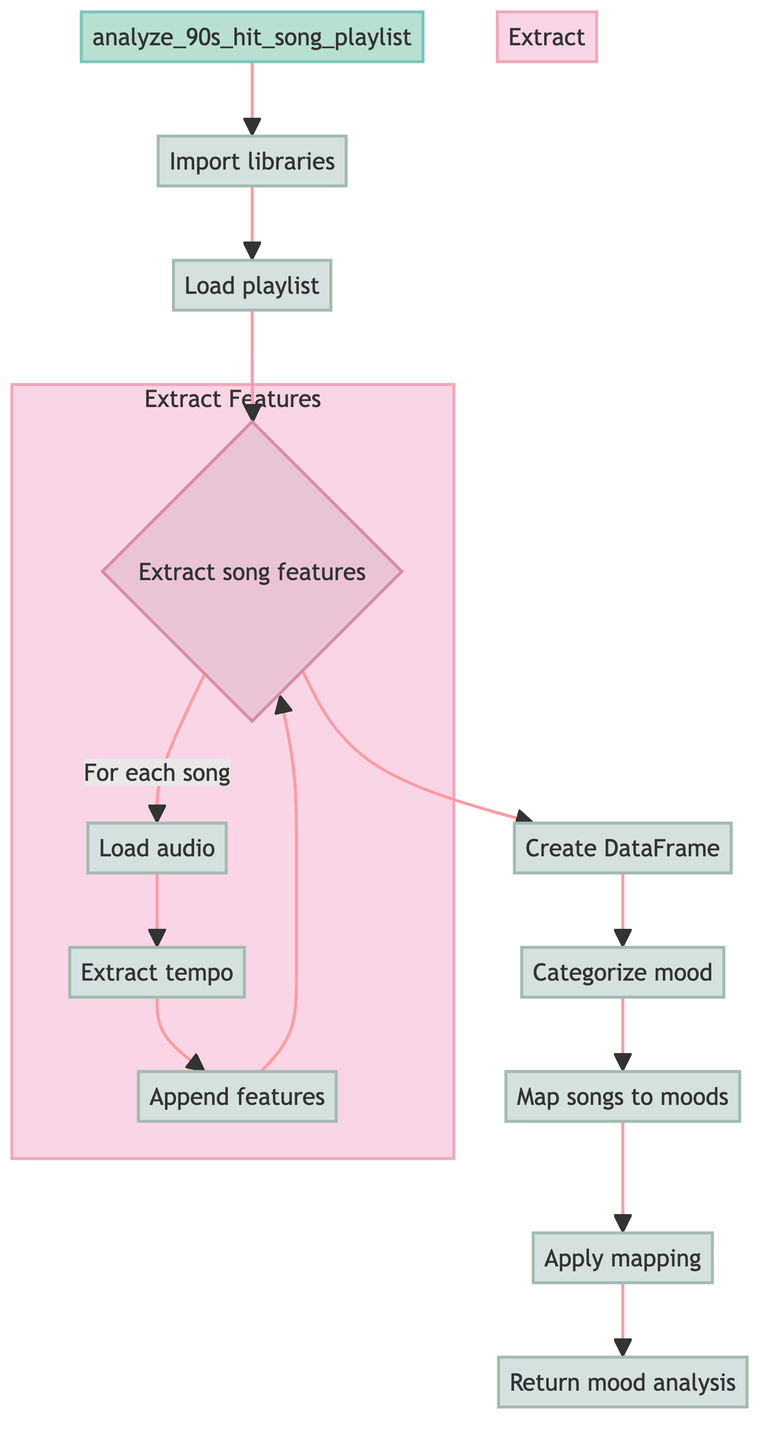What is the name of the function in this flowchart? The function's name is displayed at the top of the flowchart, indicated by the designated function shape. It is labeled as "analyze_90s_hit_song_playlist."
Answer: analyze 90s hit song playlist How many main steps are there in this function? The main steps can be counted by looking at the nodes connected directly to the function. There are eight main steps, starting from 'Import libraries' to 'Return mood analysis.'
Answer: eight What action occurs after loading the playlist? After loading the playlist, the next action is to extract song features. This is the direct next node in the flow of the diagram.
Answer: extract song features What is the categorization criteria for mood based on tempo? The mood is categorized based on the tempo; songs with a tempo greater than 120 BPM are classified as 'Energetic,' while those with a tempo of 120 BPM or less are 'Calm.' This rule is specified in the associated action for mood categorization.
Answer: energetic or calm What is the purpose of the mood mapping step? The mood mapping step is intended to map the songs to a predefined set of moods. This step takes the extracted features and corresponds them to the specific moods defined in the mapping dictionary, highlighting the relationship.
Answer: map songs to moods Which step involves loading an audio file? The step involving loading an audio file is a substep under the 'Extract song features' decision. The node specifically labeled "Load audio" indicates this action.
Answer: load audio What type of diagram is represented here? This diagram represents a flowchart of a Python function, as indicated by the flowchart structure that illustrates the sequence of actions taken within the function.
Answer: flowchart How does the function return the final output? The function returns the final output through the step labeled 'Return mood analysis,' which specifies the data included in the return statement, summarizing the analysis conducted.
Answer: return mood analysis 